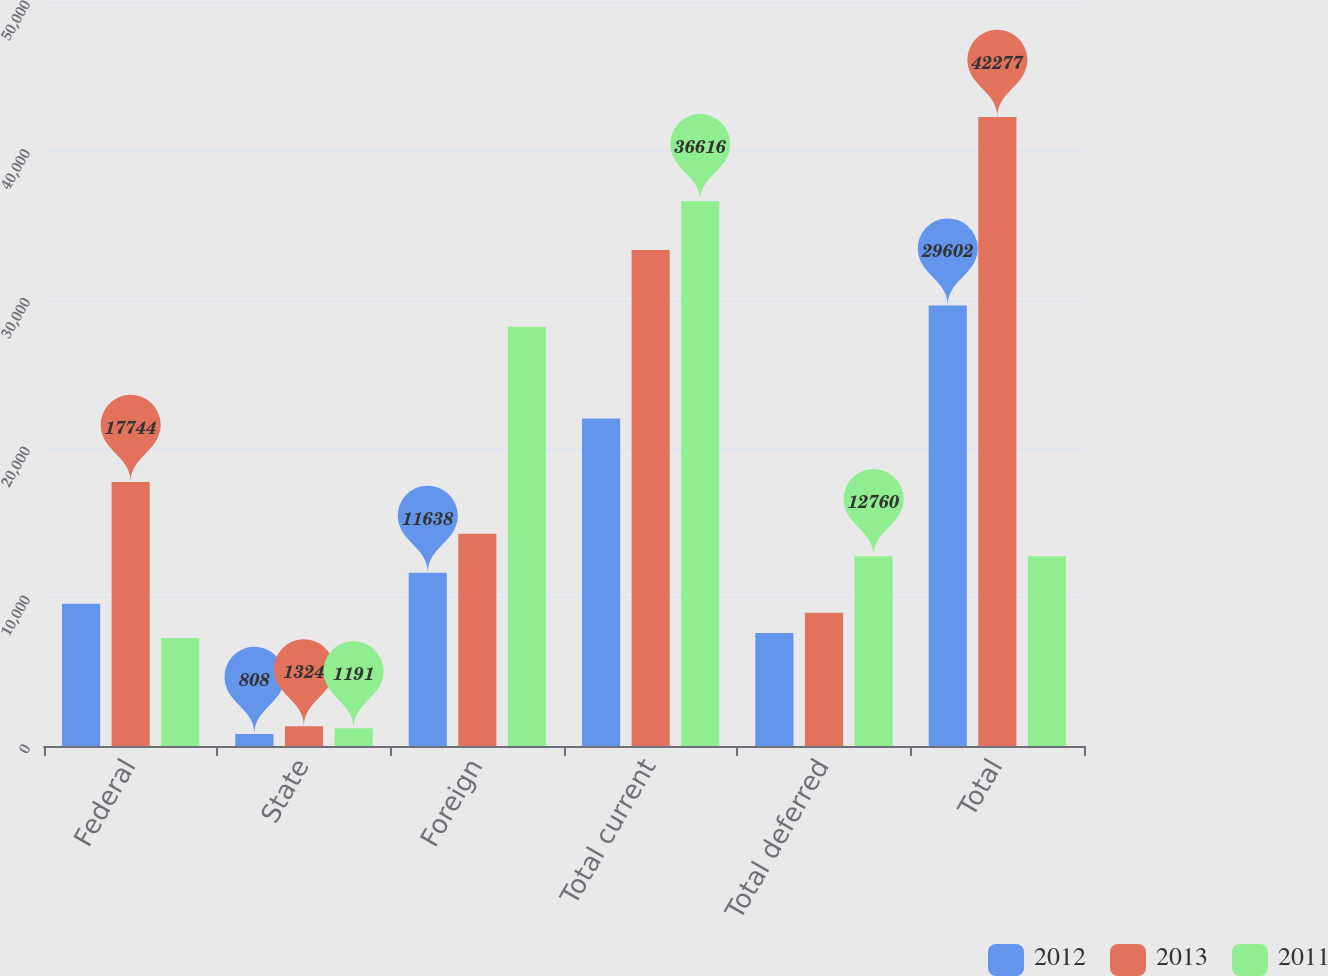Convert chart. <chart><loc_0><loc_0><loc_500><loc_500><stacked_bar_chart><ecel><fcel>Federal<fcel>State<fcel>Foreign<fcel>Total current<fcel>Total deferred<fcel>Total<nl><fcel>2012<fcel>9556<fcel>808<fcel>11638<fcel>22002<fcel>7600<fcel>29602<nl><fcel>2013<fcel>17744<fcel>1324<fcel>14258<fcel>33326<fcel>8951<fcel>42277<nl><fcel>2011<fcel>7250<fcel>1191<fcel>28175<fcel>36616<fcel>12760<fcel>12760<nl></chart> 